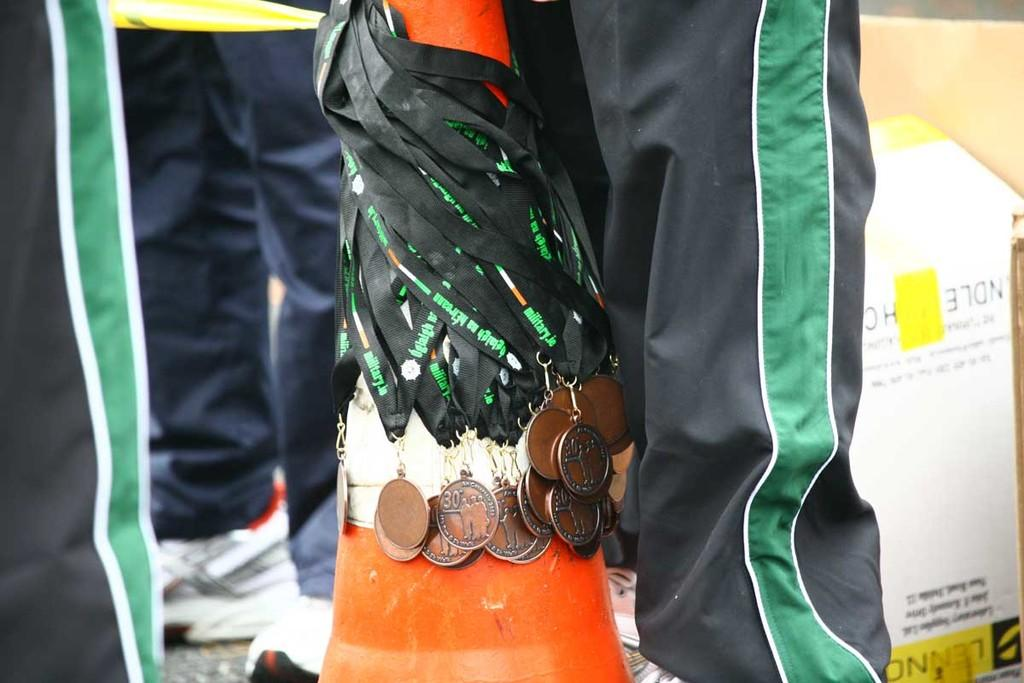What type of objects can be seen in the image? There are medals in the image. What else is present in the image besides the medals? There is a board with text in the image. Can you describe the people in the image? Legs of people are visible in the image. What type of jam is being served at the committee meeting in the image? There is no committee meeting or jam present in the image. 